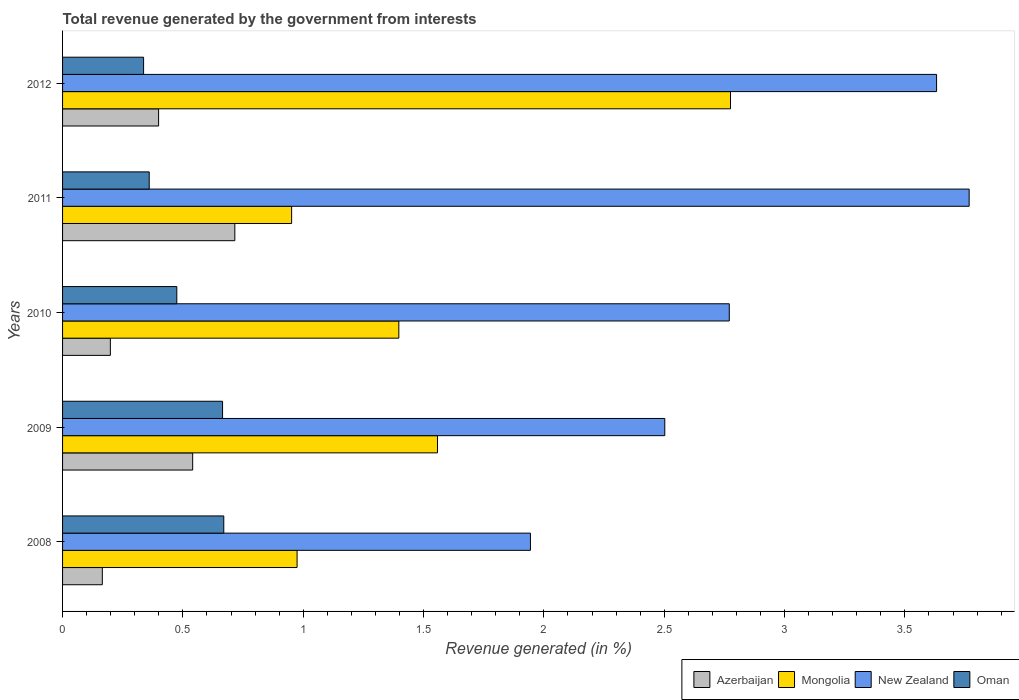How many groups of bars are there?
Offer a very short reply. 5. Are the number of bars on each tick of the Y-axis equal?
Provide a short and direct response. Yes. How many bars are there on the 3rd tick from the bottom?
Give a very brief answer. 4. What is the label of the 4th group of bars from the top?
Keep it short and to the point. 2009. In how many cases, is the number of bars for a given year not equal to the number of legend labels?
Offer a very short reply. 0. What is the total revenue generated in Azerbaijan in 2012?
Your answer should be compact. 0.4. Across all years, what is the maximum total revenue generated in Azerbaijan?
Your answer should be compact. 0.72. Across all years, what is the minimum total revenue generated in New Zealand?
Make the answer very short. 1.94. In which year was the total revenue generated in Azerbaijan maximum?
Offer a terse response. 2011. In which year was the total revenue generated in New Zealand minimum?
Your answer should be very brief. 2008. What is the total total revenue generated in Mongolia in the graph?
Provide a succinct answer. 7.66. What is the difference between the total revenue generated in New Zealand in 2008 and that in 2010?
Give a very brief answer. -0.83. What is the difference between the total revenue generated in Azerbaijan in 2010 and the total revenue generated in New Zealand in 2008?
Your answer should be compact. -1.75. What is the average total revenue generated in New Zealand per year?
Provide a short and direct response. 2.92. In the year 2008, what is the difference between the total revenue generated in New Zealand and total revenue generated in Oman?
Keep it short and to the point. 1.27. In how many years, is the total revenue generated in Azerbaijan greater than 3.1 %?
Your response must be concise. 0. What is the ratio of the total revenue generated in Azerbaijan in 2008 to that in 2010?
Offer a very short reply. 0.83. Is the difference between the total revenue generated in New Zealand in 2008 and 2011 greater than the difference between the total revenue generated in Oman in 2008 and 2011?
Give a very brief answer. No. What is the difference between the highest and the second highest total revenue generated in Mongolia?
Your answer should be compact. 1.22. What is the difference between the highest and the lowest total revenue generated in Azerbaijan?
Your answer should be very brief. 0.55. In how many years, is the total revenue generated in Mongolia greater than the average total revenue generated in Mongolia taken over all years?
Ensure brevity in your answer.  2. Is it the case that in every year, the sum of the total revenue generated in Oman and total revenue generated in Mongolia is greater than the sum of total revenue generated in New Zealand and total revenue generated in Azerbaijan?
Ensure brevity in your answer.  Yes. What does the 4th bar from the top in 2008 represents?
Your answer should be very brief. Azerbaijan. What does the 1st bar from the bottom in 2008 represents?
Provide a short and direct response. Azerbaijan. Is it the case that in every year, the sum of the total revenue generated in Mongolia and total revenue generated in Azerbaijan is greater than the total revenue generated in Oman?
Offer a very short reply. Yes. Are all the bars in the graph horizontal?
Keep it short and to the point. Yes. What is the difference between two consecutive major ticks on the X-axis?
Your answer should be compact. 0.5. How many legend labels are there?
Your answer should be very brief. 4. What is the title of the graph?
Provide a short and direct response. Total revenue generated by the government from interests. What is the label or title of the X-axis?
Your answer should be very brief. Revenue generated (in %). What is the Revenue generated (in %) of Azerbaijan in 2008?
Your answer should be very brief. 0.17. What is the Revenue generated (in %) of Mongolia in 2008?
Provide a succinct answer. 0.97. What is the Revenue generated (in %) in New Zealand in 2008?
Offer a terse response. 1.94. What is the Revenue generated (in %) in Oman in 2008?
Provide a short and direct response. 0.67. What is the Revenue generated (in %) of Azerbaijan in 2009?
Make the answer very short. 0.54. What is the Revenue generated (in %) in Mongolia in 2009?
Make the answer very short. 1.56. What is the Revenue generated (in %) of New Zealand in 2009?
Provide a short and direct response. 2.5. What is the Revenue generated (in %) of Oman in 2009?
Provide a short and direct response. 0.66. What is the Revenue generated (in %) in Azerbaijan in 2010?
Offer a terse response. 0.2. What is the Revenue generated (in %) in Mongolia in 2010?
Your response must be concise. 1.4. What is the Revenue generated (in %) in New Zealand in 2010?
Provide a succinct answer. 2.77. What is the Revenue generated (in %) of Oman in 2010?
Provide a short and direct response. 0.47. What is the Revenue generated (in %) in Azerbaijan in 2011?
Provide a succinct answer. 0.72. What is the Revenue generated (in %) in Mongolia in 2011?
Your response must be concise. 0.95. What is the Revenue generated (in %) in New Zealand in 2011?
Provide a short and direct response. 3.77. What is the Revenue generated (in %) of Oman in 2011?
Offer a very short reply. 0.36. What is the Revenue generated (in %) of Azerbaijan in 2012?
Make the answer very short. 0.4. What is the Revenue generated (in %) of Mongolia in 2012?
Offer a very short reply. 2.78. What is the Revenue generated (in %) in New Zealand in 2012?
Give a very brief answer. 3.63. What is the Revenue generated (in %) of Oman in 2012?
Your answer should be compact. 0.34. Across all years, what is the maximum Revenue generated (in %) of Azerbaijan?
Offer a very short reply. 0.72. Across all years, what is the maximum Revenue generated (in %) of Mongolia?
Give a very brief answer. 2.78. Across all years, what is the maximum Revenue generated (in %) of New Zealand?
Your answer should be compact. 3.77. Across all years, what is the maximum Revenue generated (in %) in Oman?
Ensure brevity in your answer.  0.67. Across all years, what is the minimum Revenue generated (in %) in Azerbaijan?
Your answer should be very brief. 0.17. Across all years, what is the minimum Revenue generated (in %) of Mongolia?
Your answer should be compact. 0.95. Across all years, what is the minimum Revenue generated (in %) of New Zealand?
Make the answer very short. 1.94. Across all years, what is the minimum Revenue generated (in %) of Oman?
Keep it short and to the point. 0.34. What is the total Revenue generated (in %) of Azerbaijan in the graph?
Provide a short and direct response. 2.02. What is the total Revenue generated (in %) in Mongolia in the graph?
Ensure brevity in your answer.  7.66. What is the total Revenue generated (in %) in New Zealand in the graph?
Your answer should be very brief. 14.62. What is the total Revenue generated (in %) of Oman in the graph?
Offer a very short reply. 2.51. What is the difference between the Revenue generated (in %) of Azerbaijan in 2008 and that in 2009?
Your answer should be very brief. -0.38. What is the difference between the Revenue generated (in %) in Mongolia in 2008 and that in 2009?
Your answer should be very brief. -0.58. What is the difference between the Revenue generated (in %) in New Zealand in 2008 and that in 2009?
Provide a short and direct response. -0.56. What is the difference between the Revenue generated (in %) in Oman in 2008 and that in 2009?
Provide a short and direct response. 0.01. What is the difference between the Revenue generated (in %) in Azerbaijan in 2008 and that in 2010?
Offer a terse response. -0.03. What is the difference between the Revenue generated (in %) of Mongolia in 2008 and that in 2010?
Provide a short and direct response. -0.42. What is the difference between the Revenue generated (in %) of New Zealand in 2008 and that in 2010?
Offer a very short reply. -0.83. What is the difference between the Revenue generated (in %) in Oman in 2008 and that in 2010?
Give a very brief answer. 0.2. What is the difference between the Revenue generated (in %) in Azerbaijan in 2008 and that in 2011?
Keep it short and to the point. -0.55. What is the difference between the Revenue generated (in %) in Mongolia in 2008 and that in 2011?
Ensure brevity in your answer.  0.02. What is the difference between the Revenue generated (in %) in New Zealand in 2008 and that in 2011?
Your response must be concise. -1.82. What is the difference between the Revenue generated (in %) in Oman in 2008 and that in 2011?
Offer a terse response. 0.31. What is the difference between the Revenue generated (in %) in Azerbaijan in 2008 and that in 2012?
Make the answer very short. -0.23. What is the difference between the Revenue generated (in %) in Mongolia in 2008 and that in 2012?
Your answer should be compact. -1.8. What is the difference between the Revenue generated (in %) of New Zealand in 2008 and that in 2012?
Give a very brief answer. -1.69. What is the difference between the Revenue generated (in %) of Oman in 2008 and that in 2012?
Your answer should be very brief. 0.33. What is the difference between the Revenue generated (in %) of Azerbaijan in 2009 and that in 2010?
Your response must be concise. 0.34. What is the difference between the Revenue generated (in %) in Mongolia in 2009 and that in 2010?
Provide a succinct answer. 0.16. What is the difference between the Revenue generated (in %) in New Zealand in 2009 and that in 2010?
Your response must be concise. -0.27. What is the difference between the Revenue generated (in %) of Oman in 2009 and that in 2010?
Provide a succinct answer. 0.19. What is the difference between the Revenue generated (in %) in Azerbaijan in 2009 and that in 2011?
Provide a short and direct response. -0.18. What is the difference between the Revenue generated (in %) in Mongolia in 2009 and that in 2011?
Your answer should be very brief. 0.61. What is the difference between the Revenue generated (in %) in New Zealand in 2009 and that in 2011?
Offer a terse response. -1.26. What is the difference between the Revenue generated (in %) of Oman in 2009 and that in 2011?
Offer a very short reply. 0.3. What is the difference between the Revenue generated (in %) in Azerbaijan in 2009 and that in 2012?
Give a very brief answer. 0.14. What is the difference between the Revenue generated (in %) in Mongolia in 2009 and that in 2012?
Provide a short and direct response. -1.22. What is the difference between the Revenue generated (in %) in New Zealand in 2009 and that in 2012?
Your response must be concise. -1.13. What is the difference between the Revenue generated (in %) of Oman in 2009 and that in 2012?
Your response must be concise. 0.33. What is the difference between the Revenue generated (in %) in Azerbaijan in 2010 and that in 2011?
Ensure brevity in your answer.  -0.52. What is the difference between the Revenue generated (in %) of Mongolia in 2010 and that in 2011?
Make the answer very short. 0.45. What is the difference between the Revenue generated (in %) in New Zealand in 2010 and that in 2011?
Offer a terse response. -1. What is the difference between the Revenue generated (in %) of Oman in 2010 and that in 2011?
Ensure brevity in your answer.  0.11. What is the difference between the Revenue generated (in %) of Azerbaijan in 2010 and that in 2012?
Make the answer very short. -0.2. What is the difference between the Revenue generated (in %) in Mongolia in 2010 and that in 2012?
Give a very brief answer. -1.38. What is the difference between the Revenue generated (in %) of New Zealand in 2010 and that in 2012?
Provide a succinct answer. -0.86. What is the difference between the Revenue generated (in %) of Oman in 2010 and that in 2012?
Your answer should be very brief. 0.14. What is the difference between the Revenue generated (in %) of Azerbaijan in 2011 and that in 2012?
Your answer should be compact. 0.32. What is the difference between the Revenue generated (in %) in Mongolia in 2011 and that in 2012?
Your answer should be compact. -1.82. What is the difference between the Revenue generated (in %) of New Zealand in 2011 and that in 2012?
Give a very brief answer. 0.14. What is the difference between the Revenue generated (in %) of Oman in 2011 and that in 2012?
Ensure brevity in your answer.  0.02. What is the difference between the Revenue generated (in %) in Azerbaijan in 2008 and the Revenue generated (in %) in Mongolia in 2009?
Keep it short and to the point. -1.39. What is the difference between the Revenue generated (in %) of Azerbaijan in 2008 and the Revenue generated (in %) of New Zealand in 2009?
Your answer should be compact. -2.34. What is the difference between the Revenue generated (in %) of Azerbaijan in 2008 and the Revenue generated (in %) of Oman in 2009?
Offer a very short reply. -0.5. What is the difference between the Revenue generated (in %) of Mongolia in 2008 and the Revenue generated (in %) of New Zealand in 2009?
Give a very brief answer. -1.53. What is the difference between the Revenue generated (in %) in Mongolia in 2008 and the Revenue generated (in %) in Oman in 2009?
Offer a very short reply. 0.31. What is the difference between the Revenue generated (in %) of New Zealand in 2008 and the Revenue generated (in %) of Oman in 2009?
Make the answer very short. 1.28. What is the difference between the Revenue generated (in %) of Azerbaijan in 2008 and the Revenue generated (in %) of Mongolia in 2010?
Ensure brevity in your answer.  -1.23. What is the difference between the Revenue generated (in %) in Azerbaijan in 2008 and the Revenue generated (in %) in New Zealand in 2010?
Ensure brevity in your answer.  -2.61. What is the difference between the Revenue generated (in %) in Azerbaijan in 2008 and the Revenue generated (in %) in Oman in 2010?
Ensure brevity in your answer.  -0.31. What is the difference between the Revenue generated (in %) in Mongolia in 2008 and the Revenue generated (in %) in New Zealand in 2010?
Ensure brevity in your answer.  -1.8. What is the difference between the Revenue generated (in %) of Mongolia in 2008 and the Revenue generated (in %) of Oman in 2010?
Provide a short and direct response. 0.5. What is the difference between the Revenue generated (in %) in New Zealand in 2008 and the Revenue generated (in %) in Oman in 2010?
Keep it short and to the point. 1.47. What is the difference between the Revenue generated (in %) in Azerbaijan in 2008 and the Revenue generated (in %) in Mongolia in 2011?
Provide a short and direct response. -0.79. What is the difference between the Revenue generated (in %) of Azerbaijan in 2008 and the Revenue generated (in %) of New Zealand in 2011?
Offer a terse response. -3.6. What is the difference between the Revenue generated (in %) in Azerbaijan in 2008 and the Revenue generated (in %) in Oman in 2011?
Your answer should be very brief. -0.19. What is the difference between the Revenue generated (in %) of Mongolia in 2008 and the Revenue generated (in %) of New Zealand in 2011?
Your answer should be very brief. -2.79. What is the difference between the Revenue generated (in %) of Mongolia in 2008 and the Revenue generated (in %) of Oman in 2011?
Ensure brevity in your answer.  0.61. What is the difference between the Revenue generated (in %) in New Zealand in 2008 and the Revenue generated (in %) in Oman in 2011?
Offer a terse response. 1.58. What is the difference between the Revenue generated (in %) of Azerbaijan in 2008 and the Revenue generated (in %) of Mongolia in 2012?
Provide a short and direct response. -2.61. What is the difference between the Revenue generated (in %) in Azerbaijan in 2008 and the Revenue generated (in %) in New Zealand in 2012?
Your response must be concise. -3.47. What is the difference between the Revenue generated (in %) of Azerbaijan in 2008 and the Revenue generated (in %) of Oman in 2012?
Your answer should be compact. -0.17. What is the difference between the Revenue generated (in %) in Mongolia in 2008 and the Revenue generated (in %) in New Zealand in 2012?
Provide a succinct answer. -2.66. What is the difference between the Revenue generated (in %) in Mongolia in 2008 and the Revenue generated (in %) in Oman in 2012?
Your response must be concise. 0.64. What is the difference between the Revenue generated (in %) of New Zealand in 2008 and the Revenue generated (in %) of Oman in 2012?
Make the answer very short. 1.61. What is the difference between the Revenue generated (in %) in Azerbaijan in 2009 and the Revenue generated (in %) in Mongolia in 2010?
Your answer should be compact. -0.86. What is the difference between the Revenue generated (in %) in Azerbaijan in 2009 and the Revenue generated (in %) in New Zealand in 2010?
Offer a very short reply. -2.23. What is the difference between the Revenue generated (in %) of Azerbaijan in 2009 and the Revenue generated (in %) of Oman in 2010?
Your response must be concise. 0.07. What is the difference between the Revenue generated (in %) of Mongolia in 2009 and the Revenue generated (in %) of New Zealand in 2010?
Keep it short and to the point. -1.21. What is the difference between the Revenue generated (in %) in Mongolia in 2009 and the Revenue generated (in %) in Oman in 2010?
Your response must be concise. 1.08. What is the difference between the Revenue generated (in %) in New Zealand in 2009 and the Revenue generated (in %) in Oman in 2010?
Provide a short and direct response. 2.03. What is the difference between the Revenue generated (in %) of Azerbaijan in 2009 and the Revenue generated (in %) of Mongolia in 2011?
Give a very brief answer. -0.41. What is the difference between the Revenue generated (in %) of Azerbaijan in 2009 and the Revenue generated (in %) of New Zealand in 2011?
Make the answer very short. -3.23. What is the difference between the Revenue generated (in %) in Azerbaijan in 2009 and the Revenue generated (in %) in Oman in 2011?
Keep it short and to the point. 0.18. What is the difference between the Revenue generated (in %) of Mongolia in 2009 and the Revenue generated (in %) of New Zealand in 2011?
Give a very brief answer. -2.21. What is the difference between the Revenue generated (in %) in Mongolia in 2009 and the Revenue generated (in %) in Oman in 2011?
Give a very brief answer. 1.2. What is the difference between the Revenue generated (in %) of New Zealand in 2009 and the Revenue generated (in %) of Oman in 2011?
Your answer should be very brief. 2.14. What is the difference between the Revenue generated (in %) in Azerbaijan in 2009 and the Revenue generated (in %) in Mongolia in 2012?
Your answer should be compact. -2.23. What is the difference between the Revenue generated (in %) in Azerbaijan in 2009 and the Revenue generated (in %) in New Zealand in 2012?
Make the answer very short. -3.09. What is the difference between the Revenue generated (in %) of Azerbaijan in 2009 and the Revenue generated (in %) of Oman in 2012?
Make the answer very short. 0.2. What is the difference between the Revenue generated (in %) of Mongolia in 2009 and the Revenue generated (in %) of New Zealand in 2012?
Your answer should be very brief. -2.07. What is the difference between the Revenue generated (in %) of Mongolia in 2009 and the Revenue generated (in %) of Oman in 2012?
Offer a terse response. 1.22. What is the difference between the Revenue generated (in %) of New Zealand in 2009 and the Revenue generated (in %) of Oman in 2012?
Offer a very short reply. 2.17. What is the difference between the Revenue generated (in %) in Azerbaijan in 2010 and the Revenue generated (in %) in Mongolia in 2011?
Offer a terse response. -0.75. What is the difference between the Revenue generated (in %) in Azerbaijan in 2010 and the Revenue generated (in %) in New Zealand in 2011?
Give a very brief answer. -3.57. What is the difference between the Revenue generated (in %) of Azerbaijan in 2010 and the Revenue generated (in %) of Oman in 2011?
Offer a terse response. -0.16. What is the difference between the Revenue generated (in %) of Mongolia in 2010 and the Revenue generated (in %) of New Zealand in 2011?
Offer a very short reply. -2.37. What is the difference between the Revenue generated (in %) of Mongolia in 2010 and the Revenue generated (in %) of Oman in 2011?
Make the answer very short. 1.04. What is the difference between the Revenue generated (in %) of New Zealand in 2010 and the Revenue generated (in %) of Oman in 2011?
Offer a very short reply. 2.41. What is the difference between the Revenue generated (in %) in Azerbaijan in 2010 and the Revenue generated (in %) in Mongolia in 2012?
Your answer should be very brief. -2.58. What is the difference between the Revenue generated (in %) of Azerbaijan in 2010 and the Revenue generated (in %) of New Zealand in 2012?
Your response must be concise. -3.43. What is the difference between the Revenue generated (in %) in Azerbaijan in 2010 and the Revenue generated (in %) in Oman in 2012?
Your answer should be very brief. -0.14. What is the difference between the Revenue generated (in %) of Mongolia in 2010 and the Revenue generated (in %) of New Zealand in 2012?
Your answer should be very brief. -2.23. What is the difference between the Revenue generated (in %) of Mongolia in 2010 and the Revenue generated (in %) of Oman in 2012?
Provide a succinct answer. 1.06. What is the difference between the Revenue generated (in %) of New Zealand in 2010 and the Revenue generated (in %) of Oman in 2012?
Keep it short and to the point. 2.43. What is the difference between the Revenue generated (in %) in Azerbaijan in 2011 and the Revenue generated (in %) in Mongolia in 2012?
Keep it short and to the point. -2.06. What is the difference between the Revenue generated (in %) in Azerbaijan in 2011 and the Revenue generated (in %) in New Zealand in 2012?
Your response must be concise. -2.92. What is the difference between the Revenue generated (in %) in Azerbaijan in 2011 and the Revenue generated (in %) in Oman in 2012?
Ensure brevity in your answer.  0.38. What is the difference between the Revenue generated (in %) of Mongolia in 2011 and the Revenue generated (in %) of New Zealand in 2012?
Your answer should be compact. -2.68. What is the difference between the Revenue generated (in %) in Mongolia in 2011 and the Revenue generated (in %) in Oman in 2012?
Make the answer very short. 0.62. What is the difference between the Revenue generated (in %) in New Zealand in 2011 and the Revenue generated (in %) in Oman in 2012?
Keep it short and to the point. 3.43. What is the average Revenue generated (in %) of Azerbaijan per year?
Offer a very short reply. 0.4. What is the average Revenue generated (in %) of Mongolia per year?
Ensure brevity in your answer.  1.53. What is the average Revenue generated (in %) in New Zealand per year?
Provide a succinct answer. 2.92. What is the average Revenue generated (in %) of Oman per year?
Offer a very short reply. 0.5. In the year 2008, what is the difference between the Revenue generated (in %) in Azerbaijan and Revenue generated (in %) in Mongolia?
Ensure brevity in your answer.  -0.81. In the year 2008, what is the difference between the Revenue generated (in %) in Azerbaijan and Revenue generated (in %) in New Zealand?
Offer a terse response. -1.78. In the year 2008, what is the difference between the Revenue generated (in %) of Azerbaijan and Revenue generated (in %) of Oman?
Keep it short and to the point. -0.5. In the year 2008, what is the difference between the Revenue generated (in %) in Mongolia and Revenue generated (in %) in New Zealand?
Provide a succinct answer. -0.97. In the year 2008, what is the difference between the Revenue generated (in %) in Mongolia and Revenue generated (in %) in Oman?
Provide a short and direct response. 0.3. In the year 2008, what is the difference between the Revenue generated (in %) of New Zealand and Revenue generated (in %) of Oman?
Offer a very short reply. 1.27. In the year 2009, what is the difference between the Revenue generated (in %) of Azerbaijan and Revenue generated (in %) of Mongolia?
Ensure brevity in your answer.  -1.02. In the year 2009, what is the difference between the Revenue generated (in %) of Azerbaijan and Revenue generated (in %) of New Zealand?
Your response must be concise. -1.96. In the year 2009, what is the difference between the Revenue generated (in %) of Azerbaijan and Revenue generated (in %) of Oman?
Offer a very short reply. -0.12. In the year 2009, what is the difference between the Revenue generated (in %) in Mongolia and Revenue generated (in %) in New Zealand?
Provide a short and direct response. -0.94. In the year 2009, what is the difference between the Revenue generated (in %) of Mongolia and Revenue generated (in %) of Oman?
Make the answer very short. 0.89. In the year 2009, what is the difference between the Revenue generated (in %) in New Zealand and Revenue generated (in %) in Oman?
Your answer should be very brief. 1.84. In the year 2010, what is the difference between the Revenue generated (in %) in Azerbaijan and Revenue generated (in %) in Mongolia?
Your answer should be compact. -1.2. In the year 2010, what is the difference between the Revenue generated (in %) in Azerbaijan and Revenue generated (in %) in New Zealand?
Offer a very short reply. -2.57. In the year 2010, what is the difference between the Revenue generated (in %) in Azerbaijan and Revenue generated (in %) in Oman?
Offer a terse response. -0.28. In the year 2010, what is the difference between the Revenue generated (in %) of Mongolia and Revenue generated (in %) of New Zealand?
Give a very brief answer. -1.37. In the year 2010, what is the difference between the Revenue generated (in %) of Mongolia and Revenue generated (in %) of Oman?
Provide a succinct answer. 0.92. In the year 2010, what is the difference between the Revenue generated (in %) of New Zealand and Revenue generated (in %) of Oman?
Make the answer very short. 2.3. In the year 2011, what is the difference between the Revenue generated (in %) in Azerbaijan and Revenue generated (in %) in Mongolia?
Provide a succinct answer. -0.24. In the year 2011, what is the difference between the Revenue generated (in %) of Azerbaijan and Revenue generated (in %) of New Zealand?
Give a very brief answer. -3.05. In the year 2011, what is the difference between the Revenue generated (in %) in Azerbaijan and Revenue generated (in %) in Oman?
Ensure brevity in your answer.  0.36. In the year 2011, what is the difference between the Revenue generated (in %) of Mongolia and Revenue generated (in %) of New Zealand?
Offer a terse response. -2.82. In the year 2011, what is the difference between the Revenue generated (in %) of Mongolia and Revenue generated (in %) of Oman?
Provide a short and direct response. 0.59. In the year 2011, what is the difference between the Revenue generated (in %) in New Zealand and Revenue generated (in %) in Oman?
Your response must be concise. 3.41. In the year 2012, what is the difference between the Revenue generated (in %) of Azerbaijan and Revenue generated (in %) of Mongolia?
Provide a short and direct response. -2.38. In the year 2012, what is the difference between the Revenue generated (in %) in Azerbaijan and Revenue generated (in %) in New Zealand?
Keep it short and to the point. -3.23. In the year 2012, what is the difference between the Revenue generated (in %) of Azerbaijan and Revenue generated (in %) of Oman?
Make the answer very short. 0.06. In the year 2012, what is the difference between the Revenue generated (in %) in Mongolia and Revenue generated (in %) in New Zealand?
Your response must be concise. -0.86. In the year 2012, what is the difference between the Revenue generated (in %) of Mongolia and Revenue generated (in %) of Oman?
Offer a terse response. 2.44. In the year 2012, what is the difference between the Revenue generated (in %) of New Zealand and Revenue generated (in %) of Oman?
Keep it short and to the point. 3.3. What is the ratio of the Revenue generated (in %) in Azerbaijan in 2008 to that in 2009?
Ensure brevity in your answer.  0.31. What is the ratio of the Revenue generated (in %) of Mongolia in 2008 to that in 2009?
Make the answer very short. 0.63. What is the ratio of the Revenue generated (in %) of New Zealand in 2008 to that in 2009?
Provide a short and direct response. 0.78. What is the ratio of the Revenue generated (in %) in Oman in 2008 to that in 2009?
Keep it short and to the point. 1.01. What is the ratio of the Revenue generated (in %) in Azerbaijan in 2008 to that in 2010?
Make the answer very short. 0.83. What is the ratio of the Revenue generated (in %) in Mongolia in 2008 to that in 2010?
Give a very brief answer. 0.7. What is the ratio of the Revenue generated (in %) in New Zealand in 2008 to that in 2010?
Offer a very short reply. 0.7. What is the ratio of the Revenue generated (in %) in Oman in 2008 to that in 2010?
Your response must be concise. 1.41. What is the ratio of the Revenue generated (in %) in Azerbaijan in 2008 to that in 2011?
Offer a terse response. 0.23. What is the ratio of the Revenue generated (in %) of Mongolia in 2008 to that in 2011?
Offer a terse response. 1.02. What is the ratio of the Revenue generated (in %) of New Zealand in 2008 to that in 2011?
Give a very brief answer. 0.52. What is the ratio of the Revenue generated (in %) of Oman in 2008 to that in 2011?
Offer a terse response. 1.86. What is the ratio of the Revenue generated (in %) in Azerbaijan in 2008 to that in 2012?
Provide a short and direct response. 0.41. What is the ratio of the Revenue generated (in %) of Mongolia in 2008 to that in 2012?
Provide a succinct answer. 0.35. What is the ratio of the Revenue generated (in %) in New Zealand in 2008 to that in 2012?
Offer a terse response. 0.54. What is the ratio of the Revenue generated (in %) in Oman in 2008 to that in 2012?
Your response must be concise. 1.99. What is the ratio of the Revenue generated (in %) of Azerbaijan in 2009 to that in 2010?
Your answer should be compact. 2.72. What is the ratio of the Revenue generated (in %) in Mongolia in 2009 to that in 2010?
Provide a short and direct response. 1.11. What is the ratio of the Revenue generated (in %) in New Zealand in 2009 to that in 2010?
Provide a succinct answer. 0.9. What is the ratio of the Revenue generated (in %) of Oman in 2009 to that in 2010?
Your answer should be compact. 1.4. What is the ratio of the Revenue generated (in %) of Azerbaijan in 2009 to that in 2011?
Keep it short and to the point. 0.76. What is the ratio of the Revenue generated (in %) in Mongolia in 2009 to that in 2011?
Offer a very short reply. 1.64. What is the ratio of the Revenue generated (in %) of New Zealand in 2009 to that in 2011?
Provide a succinct answer. 0.66. What is the ratio of the Revenue generated (in %) of Oman in 2009 to that in 2011?
Make the answer very short. 1.85. What is the ratio of the Revenue generated (in %) of Azerbaijan in 2009 to that in 2012?
Your response must be concise. 1.35. What is the ratio of the Revenue generated (in %) in Mongolia in 2009 to that in 2012?
Make the answer very short. 0.56. What is the ratio of the Revenue generated (in %) in New Zealand in 2009 to that in 2012?
Ensure brevity in your answer.  0.69. What is the ratio of the Revenue generated (in %) in Oman in 2009 to that in 2012?
Make the answer very short. 1.97. What is the ratio of the Revenue generated (in %) of Azerbaijan in 2010 to that in 2011?
Give a very brief answer. 0.28. What is the ratio of the Revenue generated (in %) in Mongolia in 2010 to that in 2011?
Offer a very short reply. 1.47. What is the ratio of the Revenue generated (in %) of New Zealand in 2010 to that in 2011?
Your answer should be very brief. 0.74. What is the ratio of the Revenue generated (in %) in Oman in 2010 to that in 2011?
Ensure brevity in your answer.  1.32. What is the ratio of the Revenue generated (in %) of Azerbaijan in 2010 to that in 2012?
Give a very brief answer. 0.5. What is the ratio of the Revenue generated (in %) of Mongolia in 2010 to that in 2012?
Your response must be concise. 0.5. What is the ratio of the Revenue generated (in %) in New Zealand in 2010 to that in 2012?
Make the answer very short. 0.76. What is the ratio of the Revenue generated (in %) in Oman in 2010 to that in 2012?
Your answer should be compact. 1.41. What is the ratio of the Revenue generated (in %) in Azerbaijan in 2011 to that in 2012?
Ensure brevity in your answer.  1.79. What is the ratio of the Revenue generated (in %) in Mongolia in 2011 to that in 2012?
Your answer should be very brief. 0.34. What is the ratio of the Revenue generated (in %) in New Zealand in 2011 to that in 2012?
Give a very brief answer. 1.04. What is the ratio of the Revenue generated (in %) of Oman in 2011 to that in 2012?
Your answer should be compact. 1.07. What is the difference between the highest and the second highest Revenue generated (in %) of Azerbaijan?
Give a very brief answer. 0.18. What is the difference between the highest and the second highest Revenue generated (in %) of Mongolia?
Make the answer very short. 1.22. What is the difference between the highest and the second highest Revenue generated (in %) in New Zealand?
Provide a succinct answer. 0.14. What is the difference between the highest and the second highest Revenue generated (in %) in Oman?
Provide a short and direct response. 0.01. What is the difference between the highest and the lowest Revenue generated (in %) of Azerbaijan?
Ensure brevity in your answer.  0.55. What is the difference between the highest and the lowest Revenue generated (in %) of Mongolia?
Offer a terse response. 1.82. What is the difference between the highest and the lowest Revenue generated (in %) of New Zealand?
Your answer should be compact. 1.82. What is the difference between the highest and the lowest Revenue generated (in %) in Oman?
Make the answer very short. 0.33. 